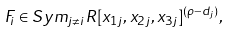Convert formula to latex. <formula><loc_0><loc_0><loc_500><loc_500>F _ { i } \in S y m _ { j \neq i } R [ x _ { 1 j } , x _ { 2 j } , x _ { 3 j } ] ^ { ( \rho - d _ { j } ) } ,</formula> 